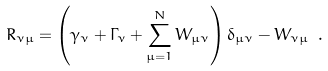<formula> <loc_0><loc_0><loc_500><loc_500>R _ { \nu \mu } = \left ( \gamma _ { \nu } + \Gamma _ { \nu } + \sum _ { \mu = 1 } ^ { N } W _ { \mu \nu } \right ) \delta _ { \mu \nu } - W _ { \nu \mu } \ .</formula> 